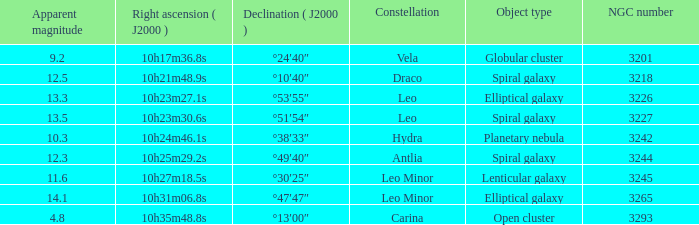What is the sum of NGC numbers for Constellation vela? 3201.0. 